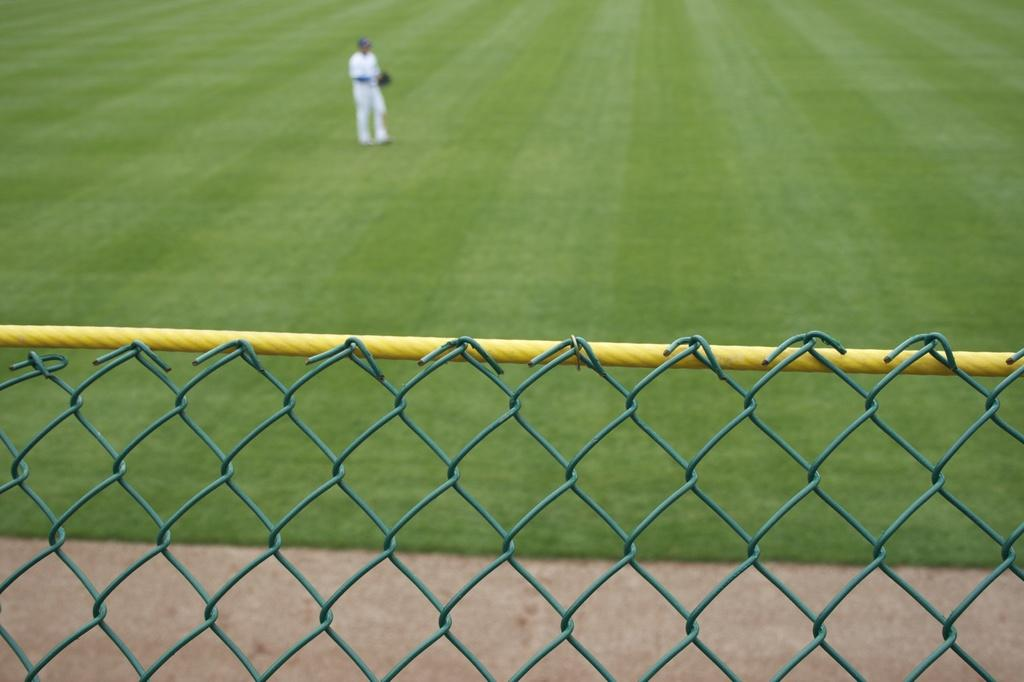What is the primary subject of the image? There is a person standing in the image. What is the person standing on? The person is standing on grass. What other object can be seen in the image? There is a fence in the image. What type of cattle can be seen grazing on the grass in the image? There are no cattle present in the image; it only features a person standing on grass and a fence. 